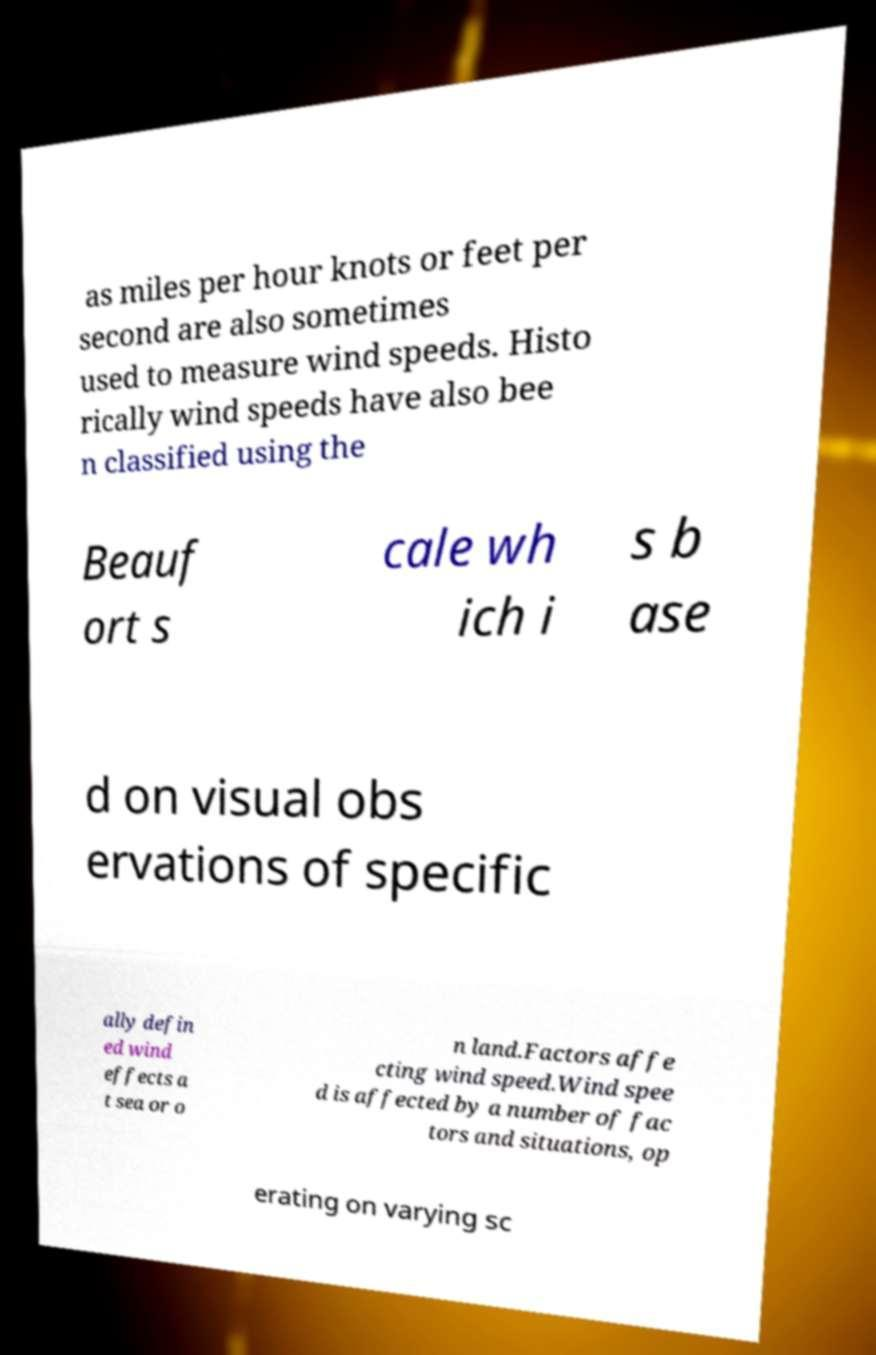What messages or text are displayed in this image? I need them in a readable, typed format. as miles per hour knots or feet per second are also sometimes used to measure wind speeds. Histo rically wind speeds have also bee n classified using the Beauf ort s cale wh ich i s b ase d on visual obs ervations of specific ally defin ed wind effects a t sea or o n land.Factors affe cting wind speed.Wind spee d is affected by a number of fac tors and situations, op erating on varying sc 